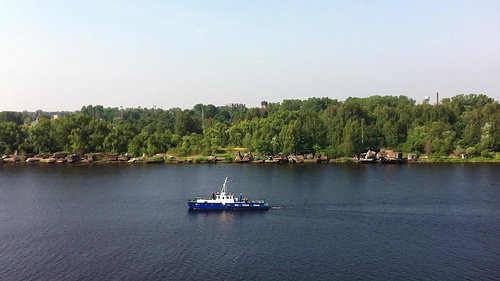What activities might be popular in this river setting? Given the calm waters and the presence of a boat dock, activities such as leisure boating, fishing, and perhaps kayaking would be popular. The scenic beauty also suggests that photography and bird watching could be common pursuits for visitors. 